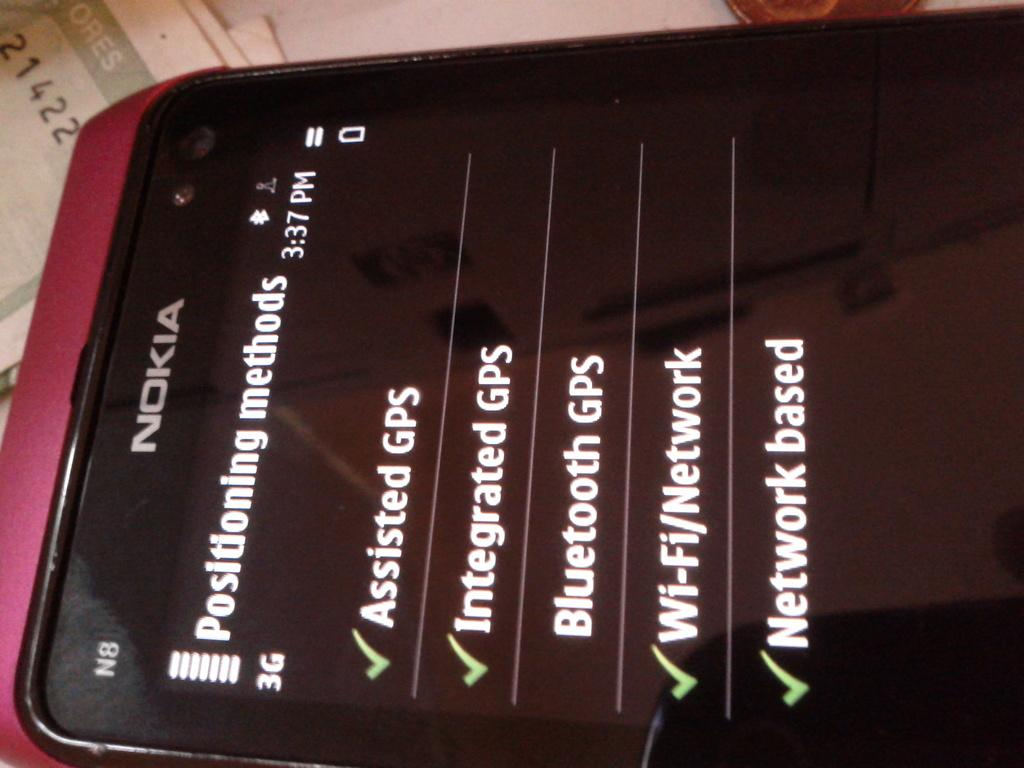<image>
Render a clear and concise summary of the photo. A Nokia smartphone with an app detailing positioning methods. 